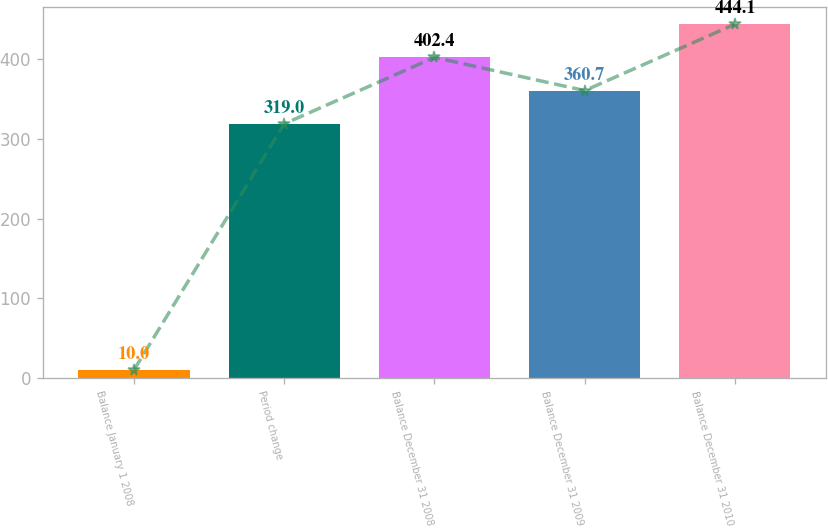Convert chart to OTSL. <chart><loc_0><loc_0><loc_500><loc_500><bar_chart><fcel>Balance January 1 2008<fcel>Period change<fcel>Balance December 31 2008<fcel>Balance December 31 2009<fcel>Balance December 31 2010<nl><fcel>10<fcel>319<fcel>402.4<fcel>360.7<fcel>444.1<nl></chart> 